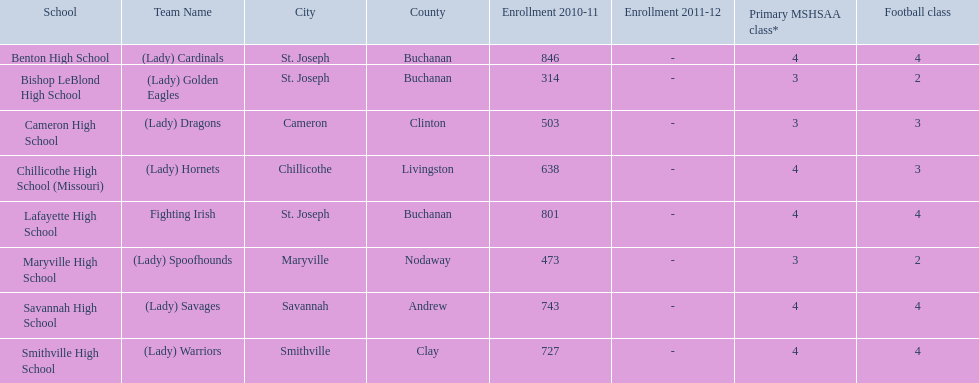What are the names of the schools? Benton High School, Bishop LeBlond High School, Cameron High School, Chillicothe High School (Missouri), Lafayette High School, Maryville High School, Savannah High School, Smithville High School. Of those, which had a total enrollment of less than 500? Bishop LeBlond High School, Maryville High School. And of those, which had the lowest enrollment? Bishop LeBlond High School. 